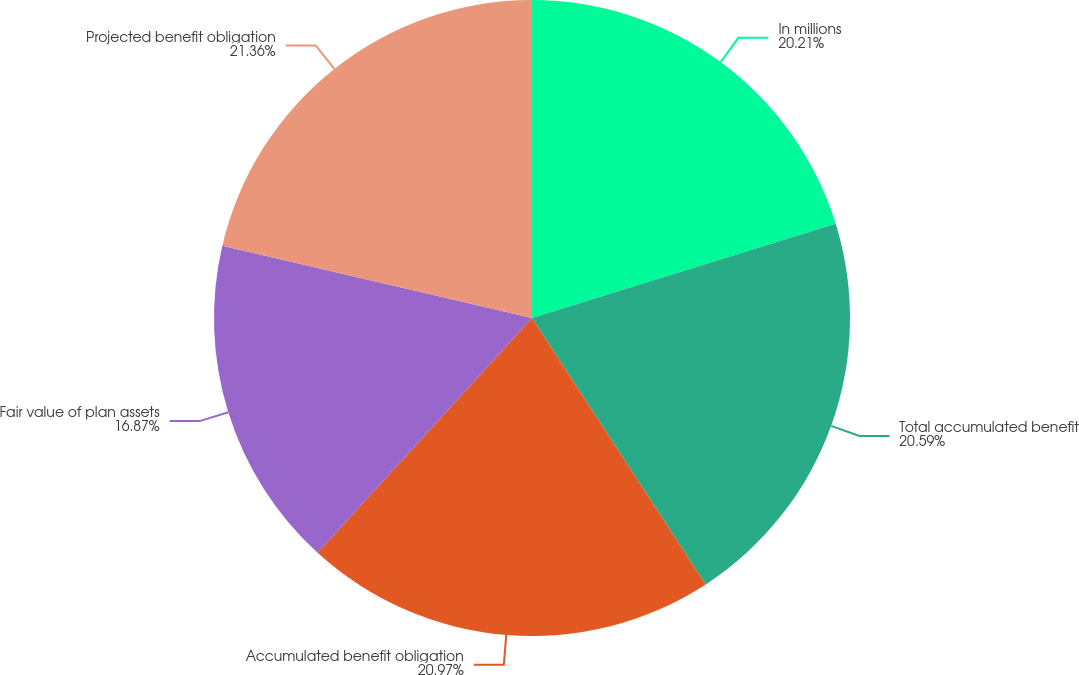<chart> <loc_0><loc_0><loc_500><loc_500><pie_chart><fcel>In millions<fcel>Total accumulated benefit<fcel>Accumulated benefit obligation<fcel>Fair value of plan assets<fcel>Projected benefit obligation<nl><fcel>20.21%<fcel>20.59%<fcel>20.97%<fcel>16.87%<fcel>21.35%<nl></chart> 